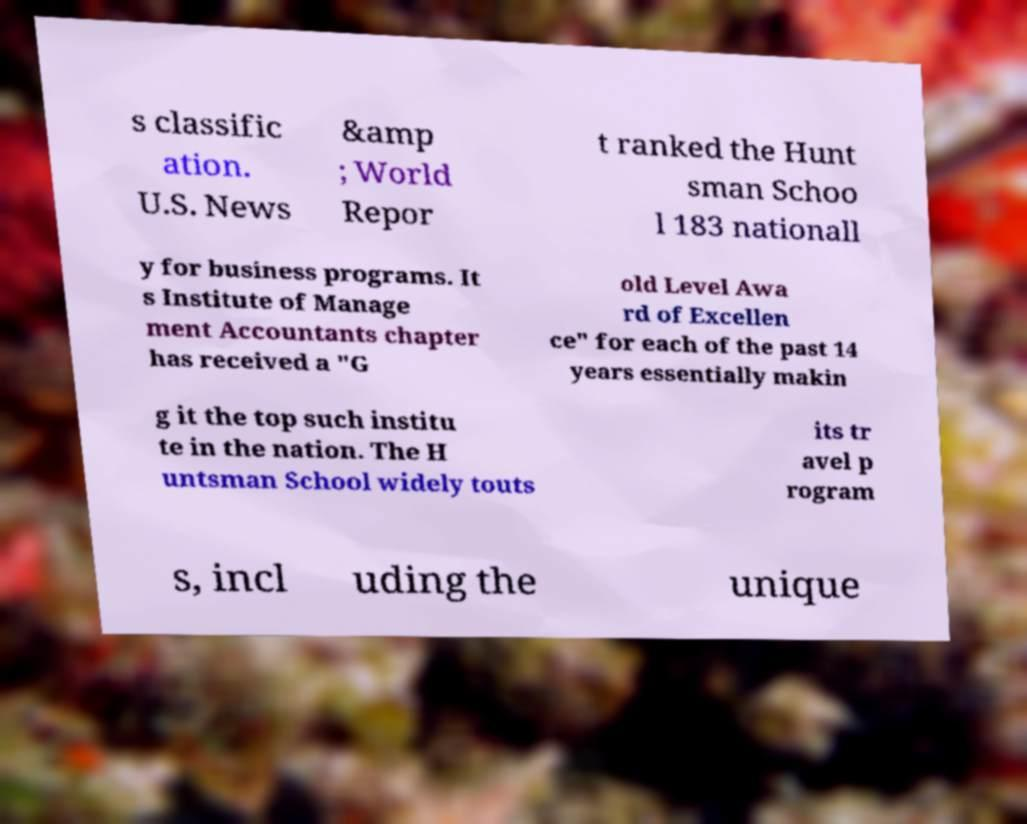For documentation purposes, I need the text within this image transcribed. Could you provide that? s classific ation. U.S. News &amp ; World Repor t ranked the Hunt sman Schoo l 183 nationall y for business programs. It s Institute of Manage ment Accountants chapter has received a "G old Level Awa rd of Excellen ce" for each of the past 14 years essentially makin g it the top such institu te in the nation. The H untsman School widely touts its tr avel p rogram s, incl uding the unique 